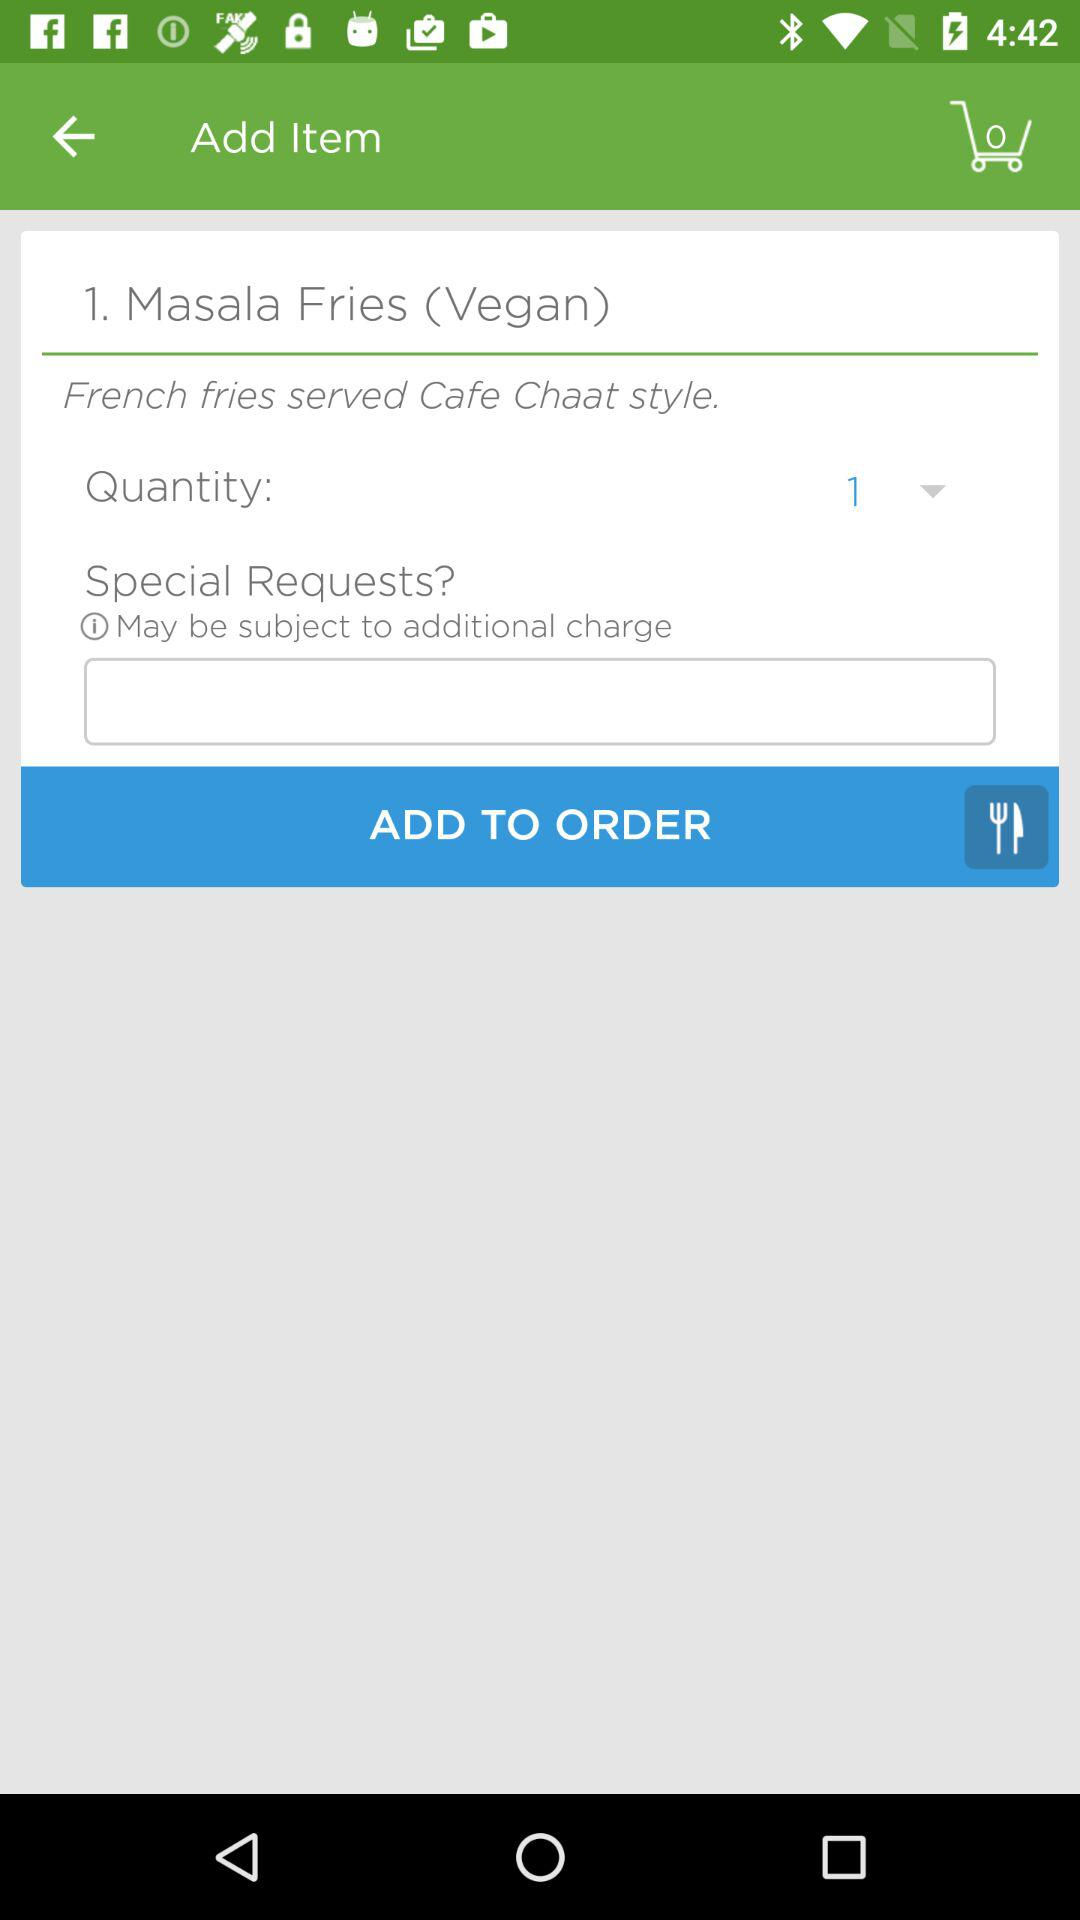Which item is added for order? The item that was added to the cart is Masala Fries (Vegan). 